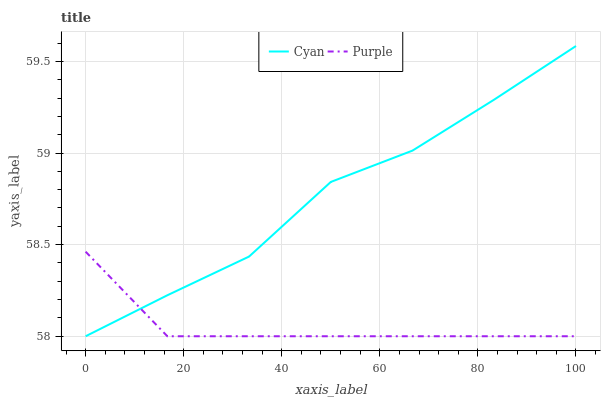Does Purple have the minimum area under the curve?
Answer yes or no. Yes. Does Cyan have the maximum area under the curve?
Answer yes or no. Yes. Does Cyan have the minimum area under the curve?
Answer yes or no. No. Is Purple the smoothest?
Answer yes or no. Yes. Is Cyan the roughest?
Answer yes or no. Yes. Is Cyan the smoothest?
Answer yes or no. No. Does Cyan have the highest value?
Answer yes or no. Yes. 